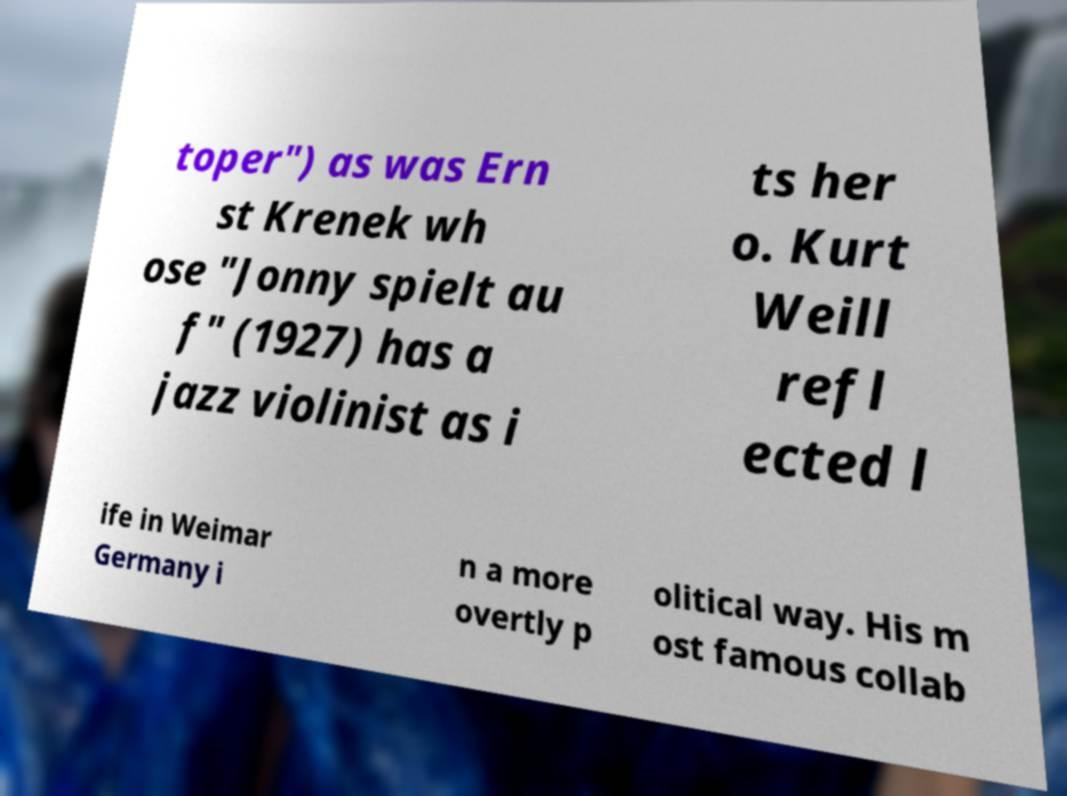I need the written content from this picture converted into text. Can you do that? toper") as was Ern st Krenek wh ose "Jonny spielt au f" (1927) has a jazz violinist as i ts her o. Kurt Weill refl ected l ife in Weimar Germany i n a more overtly p olitical way. His m ost famous collab 